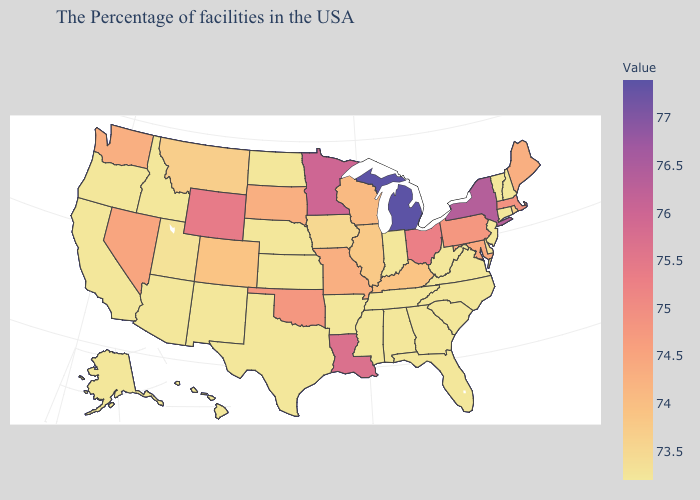Does Ohio have a higher value than Michigan?
Concise answer only. No. Which states have the lowest value in the MidWest?
Write a very short answer. Indiana, Kansas, Nebraska, North Dakota. Is the legend a continuous bar?
Give a very brief answer. Yes. Does Kentucky have the highest value in the USA?
Keep it brief. No. Does Massachusetts have the highest value in the Northeast?
Give a very brief answer. No. 